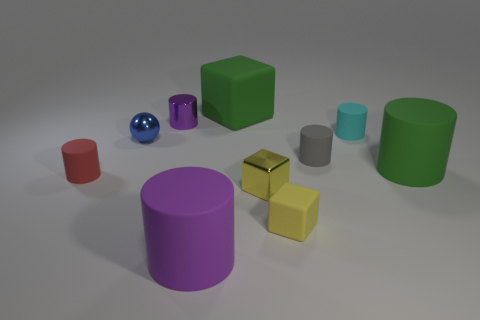Subtract all tiny cylinders. How many cylinders are left? 2 Subtract all gray cylinders. How many cylinders are left? 5 Subtract all blue blocks. How many purple cylinders are left? 2 Subtract 5 cylinders. How many cylinders are left? 1 Subtract all balls. How many objects are left? 9 Subtract all cyan spheres. Subtract all brown cubes. How many spheres are left? 1 Subtract all small red cylinders. Subtract all blue metal spheres. How many objects are left? 8 Add 6 blue objects. How many blue objects are left? 7 Add 2 large purple cubes. How many large purple cubes exist? 2 Subtract 0 gray balls. How many objects are left? 10 